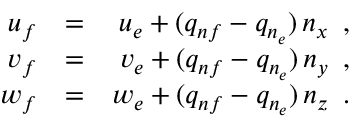<formula> <loc_0><loc_0><loc_500><loc_500>\begin{array} { r l r } { { u _ { f } } } & { = } } & { { u _ { e } + ( q _ { n f } - q _ { n _ { e } } ) \, n _ { x } \, , } } \\ { { v _ { f } } } & { = } } & { { v _ { e } + ( q _ { n f } - q _ { n _ { e } } ) \, n _ { y } \, , } } \\ { { w _ { f } } } & { = } } & { { w _ { e } + ( q _ { n f } - q _ { n _ { e } } ) \, n _ { z } \, . } } \end{array}</formula> 